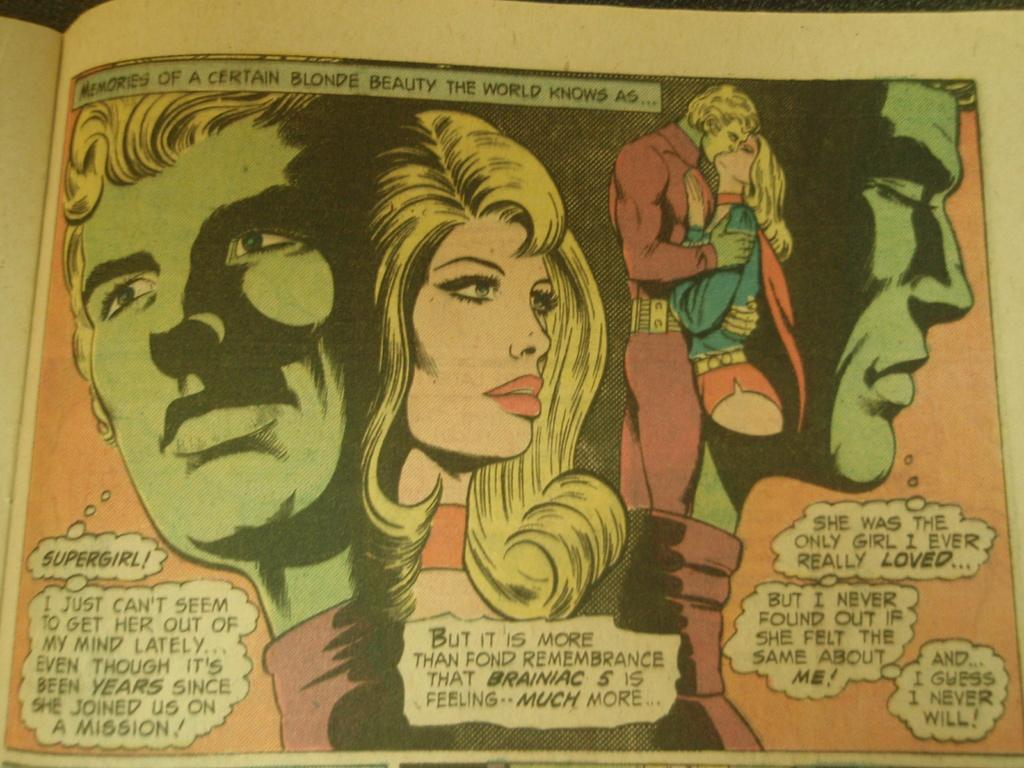<image>
Share a concise interpretation of the image provided. Supergirl is described as a blonde beauty in a cartoon panel. 